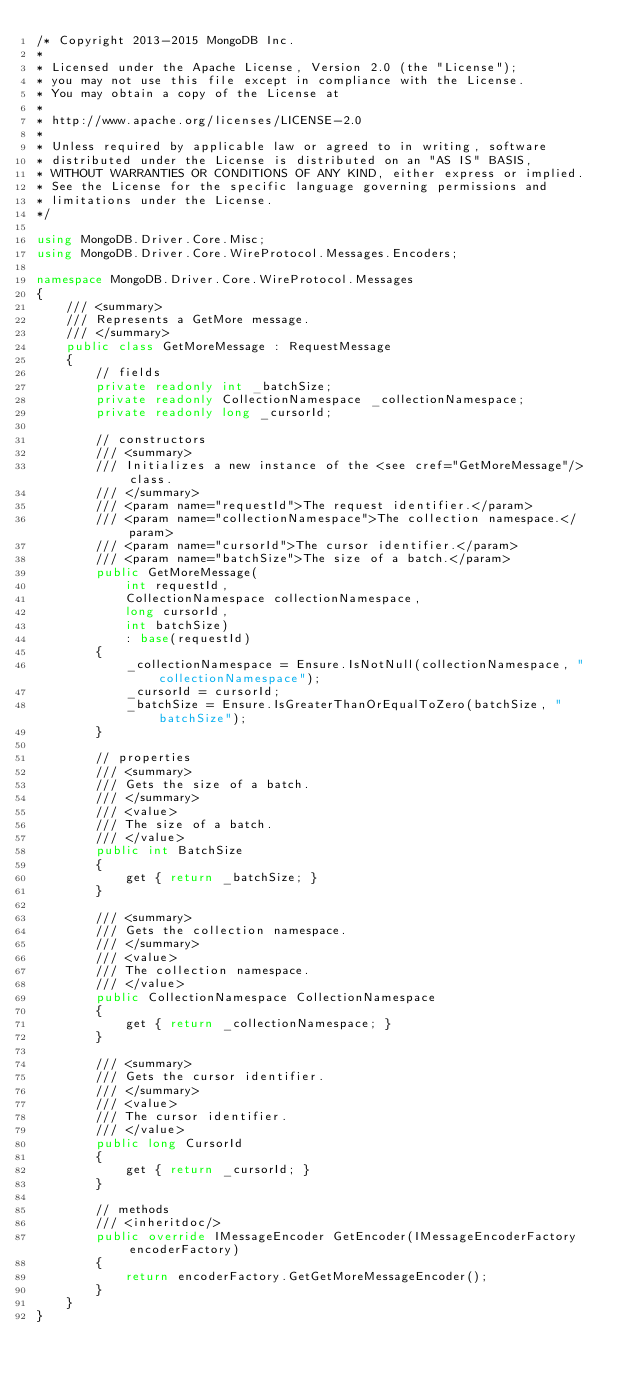<code> <loc_0><loc_0><loc_500><loc_500><_C#_>/* Copyright 2013-2015 MongoDB Inc.
*
* Licensed under the Apache License, Version 2.0 (the "License");
* you may not use this file except in compliance with the License.
* You may obtain a copy of the License at
*
* http://www.apache.org/licenses/LICENSE-2.0
*
* Unless required by applicable law or agreed to in writing, software
* distributed under the License is distributed on an "AS IS" BASIS,
* WITHOUT WARRANTIES OR CONDITIONS OF ANY KIND, either express or implied.
* See the License for the specific language governing permissions and
* limitations under the License.
*/

using MongoDB.Driver.Core.Misc;
using MongoDB.Driver.Core.WireProtocol.Messages.Encoders;

namespace MongoDB.Driver.Core.WireProtocol.Messages
{
    /// <summary>
    /// Represents a GetMore message.
    /// </summary>
    public class GetMoreMessage : RequestMessage
    {
        // fields
        private readonly int _batchSize;
        private readonly CollectionNamespace _collectionNamespace;
        private readonly long _cursorId;

        // constructors
        /// <summary>
        /// Initializes a new instance of the <see cref="GetMoreMessage"/> class.
        /// </summary>
        /// <param name="requestId">The request identifier.</param>
        /// <param name="collectionNamespace">The collection namespace.</param>
        /// <param name="cursorId">The cursor identifier.</param>
        /// <param name="batchSize">The size of a batch.</param>
        public GetMoreMessage(
            int requestId,
            CollectionNamespace collectionNamespace,
            long cursorId,
            int batchSize)
            : base(requestId)
        {
            _collectionNamespace = Ensure.IsNotNull(collectionNamespace, "collectionNamespace");
            _cursorId = cursorId;
            _batchSize = Ensure.IsGreaterThanOrEqualToZero(batchSize, "batchSize");
        }

        // properties
        /// <summary>
        /// Gets the size of a batch.
        /// </summary>
        /// <value>
        /// The size of a batch.
        /// </value>
        public int BatchSize
        {
            get { return _batchSize; }
        }

        /// <summary>
        /// Gets the collection namespace.
        /// </summary>
        /// <value>
        /// The collection namespace.
        /// </value>
        public CollectionNamespace CollectionNamespace
        {
            get { return _collectionNamespace; }
        }

        /// <summary>
        /// Gets the cursor identifier.
        /// </summary>
        /// <value>
        /// The cursor identifier.
        /// </value>
        public long CursorId
        {
            get { return _cursorId; }
        }

        // methods
        /// <inheritdoc/>
        public override IMessageEncoder GetEncoder(IMessageEncoderFactory encoderFactory)
        {
            return encoderFactory.GetGetMoreMessageEncoder();
        }
    }
}
</code> 